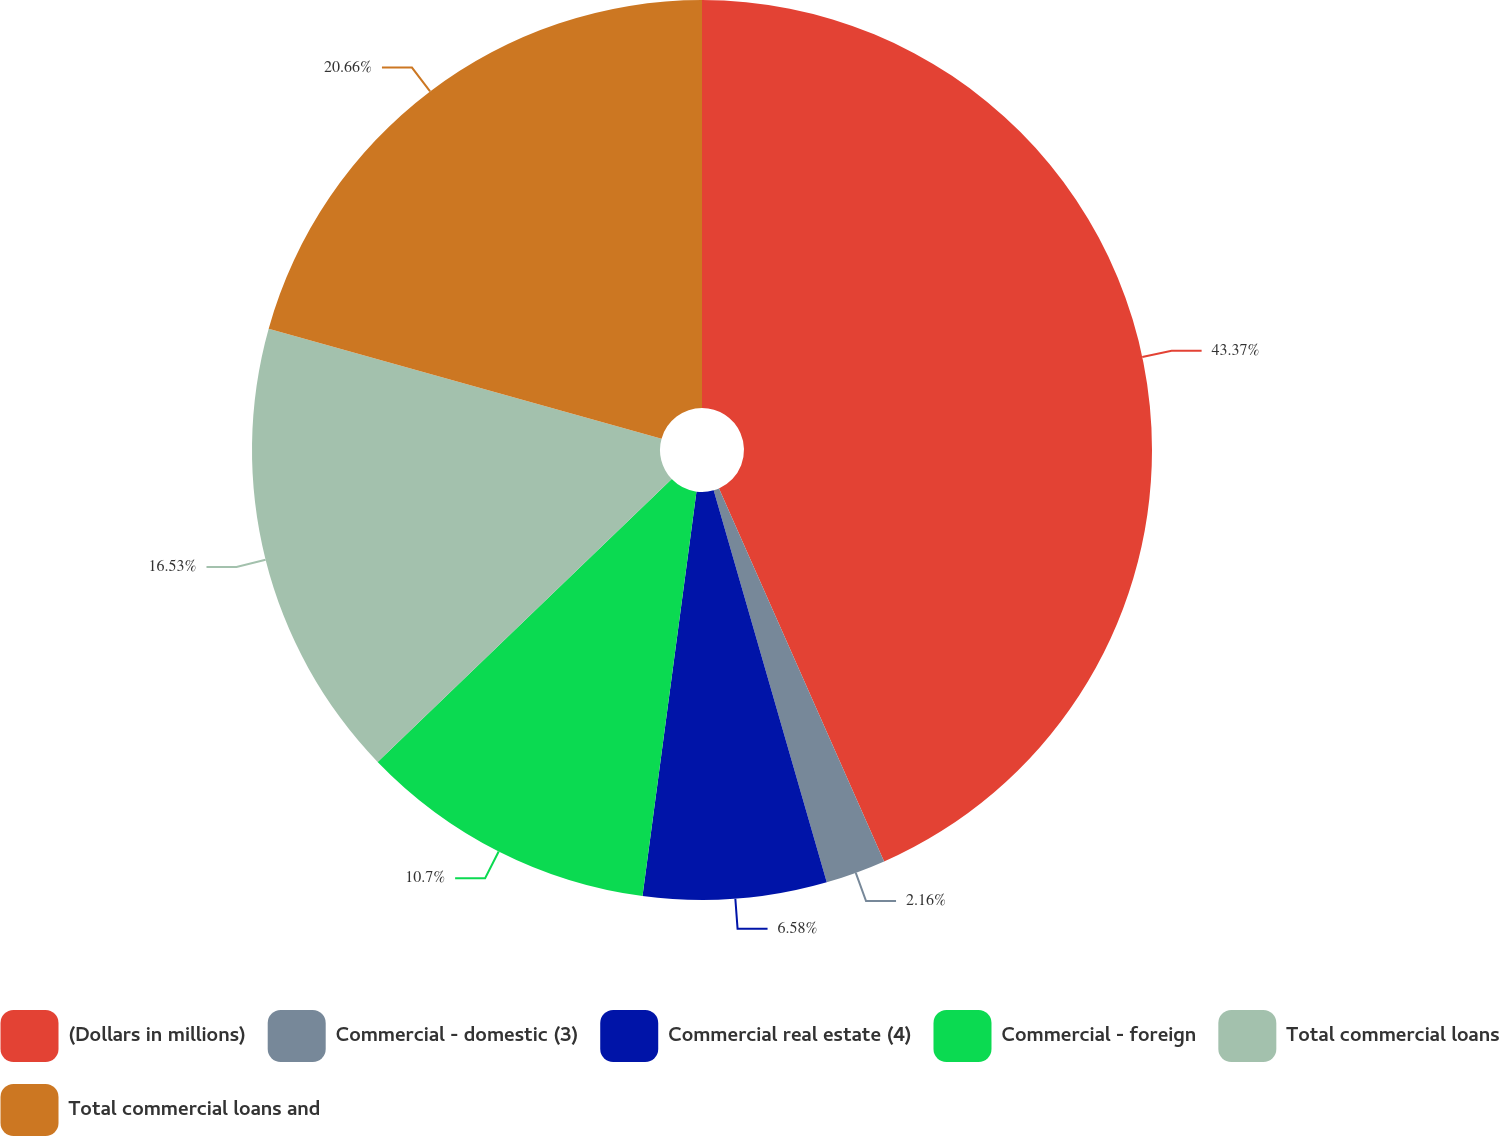<chart> <loc_0><loc_0><loc_500><loc_500><pie_chart><fcel>(Dollars in millions)<fcel>Commercial - domestic (3)<fcel>Commercial real estate (4)<fcel>Commercial - foreign<fcel>Total commercial loans<fcel>Total commercial loans and<nl><fcel>43.36%<fcel>2.16%<fcel>6.58%<fcel>10.7%<fcel>16.53%<fcel>20.65%<nl></chart> 